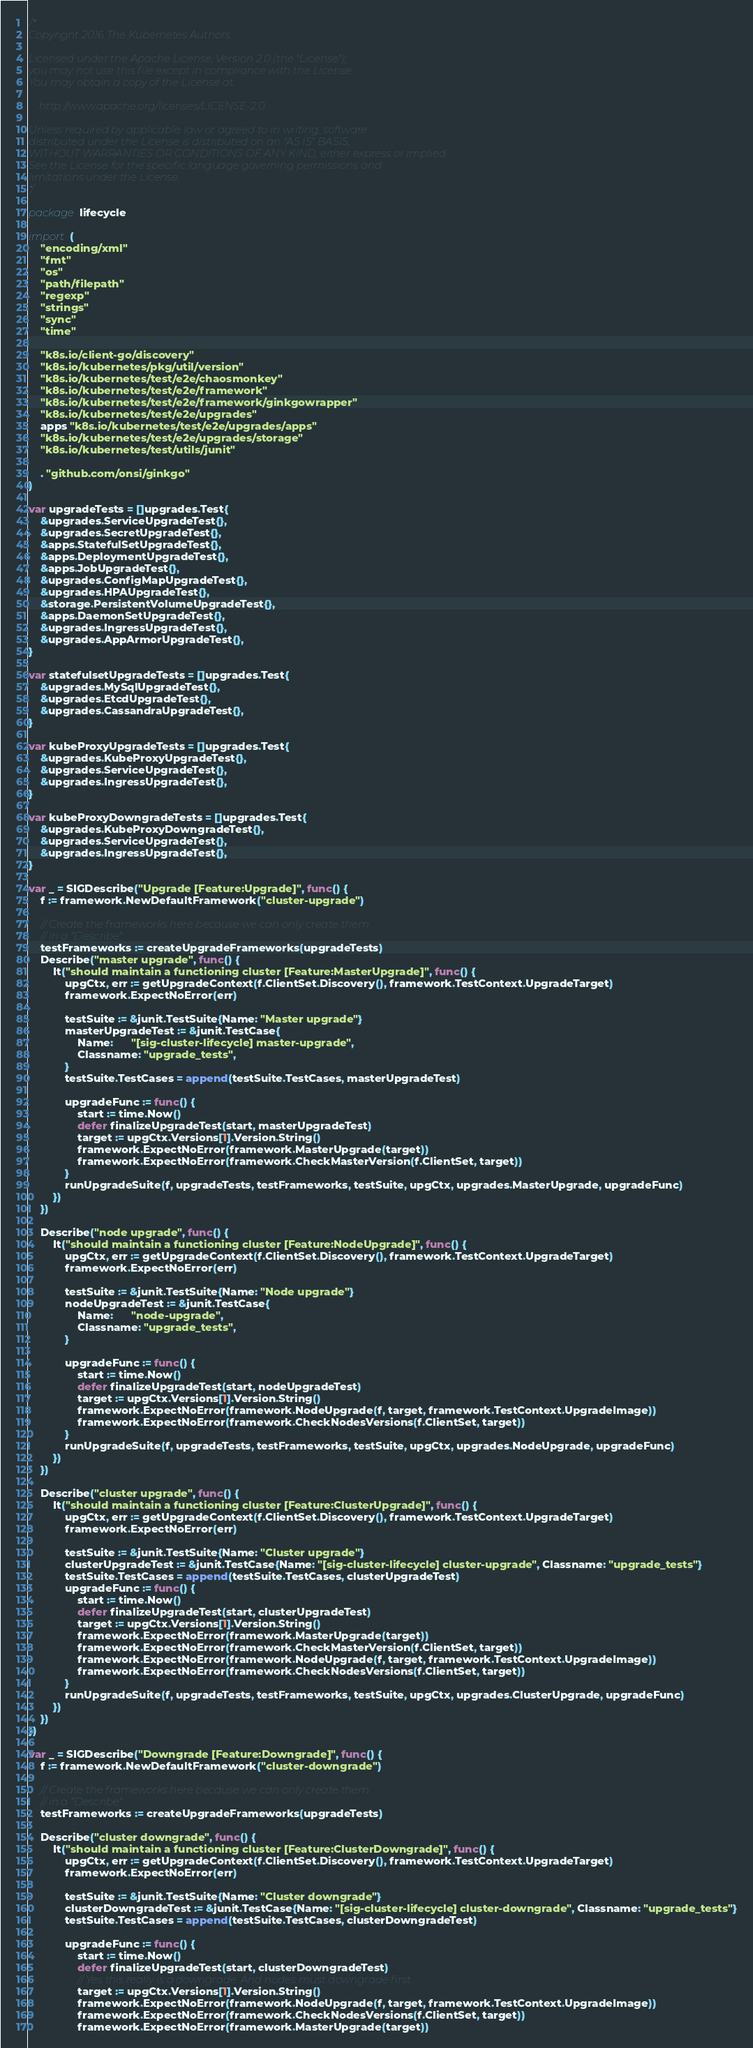<code> <loc_0><loc_0><loc_500><loc_500><_Go_>/*
Copyright 2016 The Kubernetes Authors.

Licensed under the Apache License, Version 2.0 (the "License");
you may not use this file except in compliance with the License.
You may obtain a copy of the License at

    http://www.apache.org/licenses/LICENSE-2.0

Unless required by applicable law or agreed to in writing, software
distributed under the License is distributed on an "AS IS" BASIS,
WITHOUT WARRANTIES OR CONDITIONS OF ANY KIND, either express or implied.
See the License for the specific language governing permissions and
limitations under the License.
*/

package lifecycle

import (
	"encoding/xml"
	"fmt"
	"os"
	"path/filepath"
	"regexp"
	"strings"
	"sync"
	"time"

	"k8s.io/client-go/discovery"
	"k8s.io/kubernetes/pkg/util/version"
	"k8s.io/kubernetes/test/e2e/chaosmonkey"
	"k8s.io/kubernetes/test/e2e/framework"
	"k8s.io/kubernetes/test/e2e/framework/ginkgowrapper"
	"k8s.io/kubernetes/test/e2e/upgrades"
	apps "k8s.io/kubernetes/test/e2e/upgrades/apps"
	"k8s.io/kubernetes/test/e2e/upgrades/storage"
	"k8s.io/kubernetes/test/utils/junit"

	. "github.com/onsi/ginkgo"
)

var upgradeTests = []upgrades.Test{
	&upgrades.ServiceUpgradeTest{},
	&upgrades.SecretUpgradeTest{},
	&apps.StatefulSetUpgradeTest{},
	&apps.DeploymentUpgradeTest{},
	&apps.JobUpgradeTest{},
	&upgrades.ConfigMapUpgradeTest{},
	&upgrades.HPAUpgradeTest{},
	&storage.PersistentVolumeUpgradeTest{},
	&apps.DaemonSetUpgradeTest{},
	&upgrades.IngressUpgradeTest{},
	&upgrades.AppArmorUpgradeTest{},
}

var statefulsetUpgradeTests = []upgrades.Test{
	&upgrades.MySqlUpgradeTest{},
	&upgrades.EtcdUpgradeTest{},
	&upgrades.CassandraUpgradeTest{},
}

var kubeProxyUpgradeTests = []upgrades.Test{
	&upgrades.KubeProxyUpgradeTest{},
	&upgrades.ServiceUpgradeTest{},
	&upgrades.IngressUpgradeTest{},
}

var kubeProxyDowngradeTests = []upgrades.Test{
	&upgrades.KubeProxyDowngradeTest{},
	&upgrades.ServiceUpgradeTest{},
	&upgrades.IngressUpgradeTest{},
}

var _ = SIGDescribe("Upgrade [Feature:Upgrade]", func() {
	f := framework.NewDefaultFramework("cluster-upgrade")

	// Create the frameworks here because we can only create them
	// in a "Describe".
	testFrameworks := createUpgradeFrameworks(upgradeTests)
	Describe("master upgrade", func() {
		It("should maintain a functioning cluster [Feature:MasterUpgrade]", func() {
			upgCtx, err := getUpgradeContext(f.ClientSet.Discovery(), framework.TestContext.UpgradeTarget)
			framework.ExpectNoError(err)

			testSuite := &junit.TestSuite{Name: "Master upgrade"}
			masterUpgradeTest := &junit.TestCase{
				Name:      "[sig-cluster-lifecycle] master-upgrade",
				Classname: "upgrade_tests",
			}
			testSuite.TestCases = append(testSuite.TestCases, masterUpgradeTest)

			upgradeFunc := func() {
				start := time.Now()
				defer finalizeUpgradeTest(start, masterUpgradeTest)
				target := upgCtx.Versions[1].Version.String()
				framework.ExpectNoError(framework.MasterUpgrade(target))
				framework.ExpectNoError(framework.CheckMasterVersion(f.ClientSet, target))
			}
			runUpgradeSuite(f, upgradeTests, testFrameworks, testSuite, upgCtx, upgrades.MasterUpgrade, upgradeFunc)
		})
	})

	Describe("node upgrade", func() {
		It("should maintain a functioning cluster [Feature:NodeUpgrade]", func() {
			upgCtx, err := getUpgradeContext(f.ClientSet.Discovery(), framework.TestContext.UpgradeTarget)
			framework.ExpectNoError(err)

			testSuite := &junit.TestSuite{Name: "Node upgrade"}
			nodeUpgradeTest := &junit.TestCase{
				Name:      "node-upgrade",
				Classname: "upgrade_tests",
			}

			upgradeFunc := func() {
				start := time.Now()
				defer finalizeUpgradeTest(start, nodeUpgradeTest)
				target := upgCtx.Versions[1].Version.String()
				framework.ExpectNoError(framework.NodeUpgrade(f, target, framework.TestContext.UpgradeImage))
				framework.ExpectNoError(framework.CheckNodesVersions(f.ClientSet, target))
			}
			runUpgradeSuite(f, upgradeTests, testFrameworks, testSuite, upgCtx, upgrades.NodeUpgrade, upgradeFunc)
		})
	})

	Describe("cluster upgrade", func() {
		It("should maintain a functioning cluster [Feature:ClusterUpgrade]", func() {
			upgCtx, err := getUpgradeContext(f.ClientSet.Discovery(), framework.TestContext.UpgradeTarget)
			framework.ExpectNoError(err)

			testSuite := &junit.TestSuite{Name: "Cluster upgrade"}
			clusterUpgradeTest := &junit.TestCase{Name: "[sig-cluster-lifecycle] cluster-upgrade", Classname: "upgrade_tests"}
			testSuite.TestCases = append(testSuite.TestCases, clusterUpgradeTest)
			upgradeFunc := func() {
				start := time.Now()
				defer finalizeUpgradeTest(start, clusterUpgradeTest)
				target := upgCtx.Versions[1].Version.String()
				framework.ExpectNoError(framework.MasterUpgrade(target))
				framework.ExpectNoError(framework.CheckMasterVersion(f.ClientSet, target))
				framework.ExpectNoError(framework.NodeUpgrade(f, target, framework.TestContext.UpgradeImage))
				framework.ExpectNoError(framework.CheckNodesVersions(f.ClientSet, target))
			}
			runUpgradeSuite(f, upgradeTests, testFrameworks, testSuite, upgCtx, upgrades.ClusterUpgrade, upgradeFunc)
		})
	})
})

var _ = SIGDescribe("Downgrade [Feature:Downgrade]", func() {
	f := framework.NewDefaultFramework("cluster-downgrade")

	// Create the frameworks here because we can only create them
	// in a "Describe".
	testFrameworks := createUpgradeFrameworks(upgradeTests)

	Describe("cluster downgrade", func() {
		It("should maintain a functioning cluster [Feature:ClusterDowngrade]", func() {
			upgCtx, err := getUpgradeContext(f.ClientSet.Discovery(), framework.TestContext.UpgradeTarget)
			framework.ExpectNoError(err)

			testSuite := &junit.TestSuite{Name: "Cluster downgrade"}
			clusterDowngradeTest := &junit.TestCase{Name: "[sig-cluster-lifecycle] cluster-downgrade", Classname: "upgrade_tests"}
			testSuite.TestCases = append(testSuite.TestCases, clusterDowngradeTest)

			upgradeFunc := func() {
				start := time.Now()
				defer finalizeUpgradeTest(start, clusterDowngradeTest)
				// Yes this really is a downgrade. And nodes must downgrade first.
				target := upgCtx.Versions[1].Version.String()
				framework.ExpectNoError(framework.NodeUpgrade(f, target, framework.TestContext.UpgradeImage))
				framework.ExpectNoError(framework.CheckNodesVersions(f.ClientSet, target))
				framework.ExpectNoError(framework.MasterUpgrade(target))</code> 